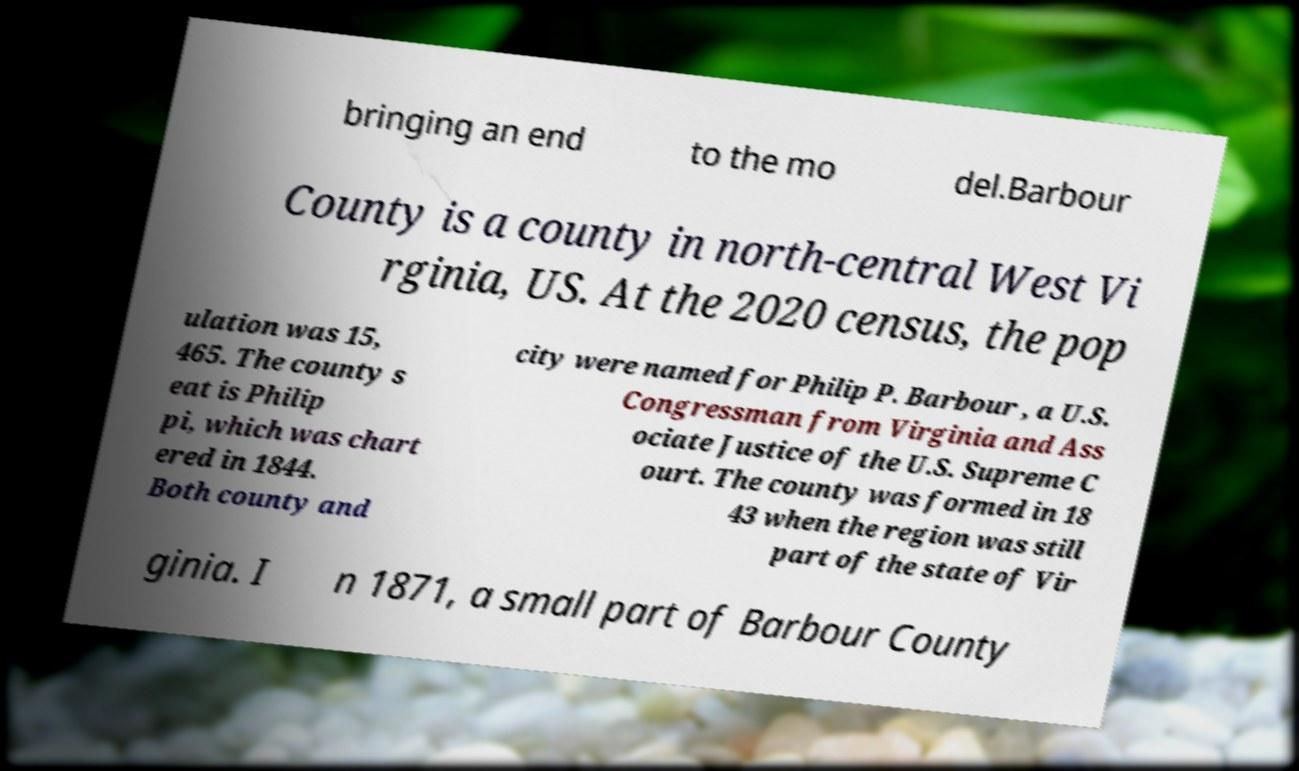For documentation purposes, I need the text within this image transcribed. Could you provide that? bringing an end to the mo del.Barbour County is a county in north-central West Vi rginia, US. At the 2020 census, the pop ulation was 15, 465. The county s eat is Philip pi, which was chart ered in 1844. Both county and city were named for Philip P. Barbour , a U.S. Congressman from Virginia and Ass ociate Justice of the U.S. Supreme C ourt. The county was formed in 18 43 when the region was still part of the state of Vir ginia. I n 1871, a small part of Barbour County 